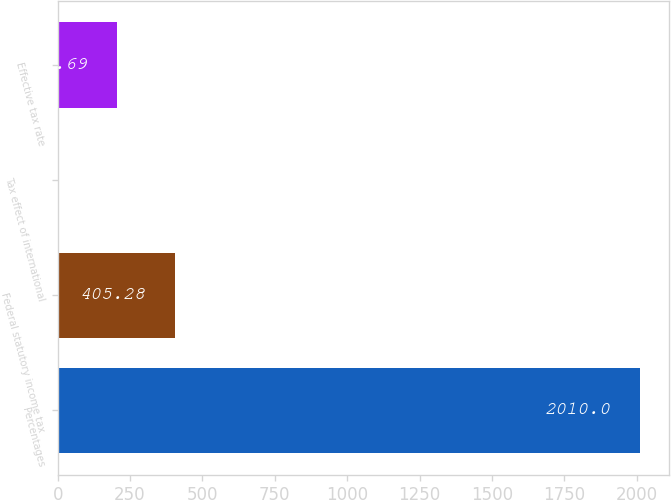<chart> <loc_0><loc_0><loc_500><loc_500><bar_chart><fcel>Percentages<fcel>Federal statutory income tax<fcel>Tax effect of international<fcel>Effective tax rate<nl><fcel>2010<fcel>405.28<fcel>4.1<fcel>204.69<nl></chart> 